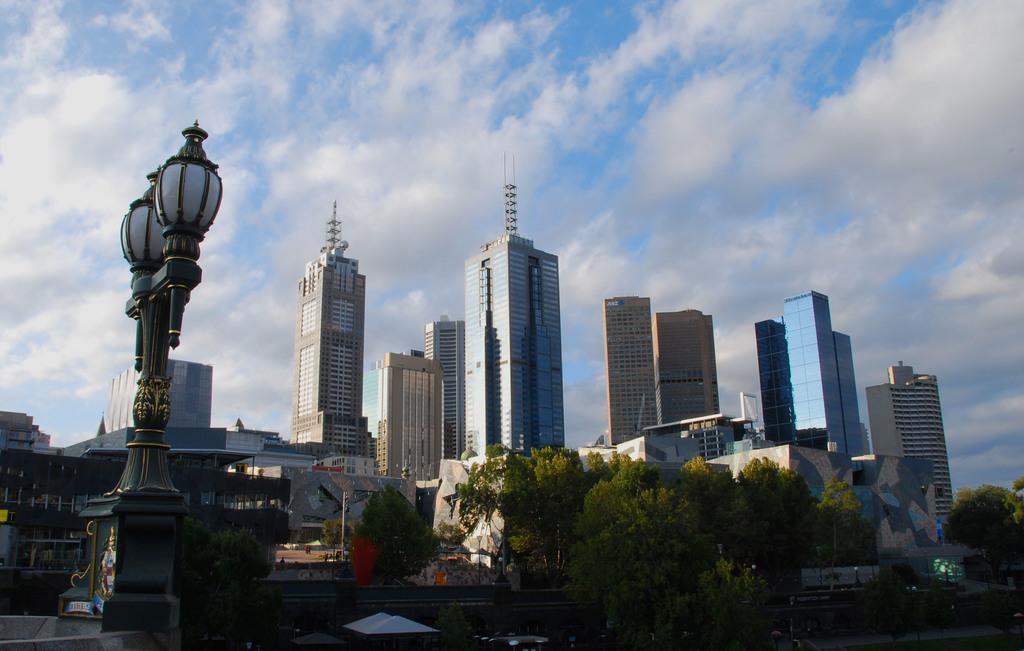Describe this image in one or two sentences. In this image there are so many different shaped buildings, street lights and trees. 